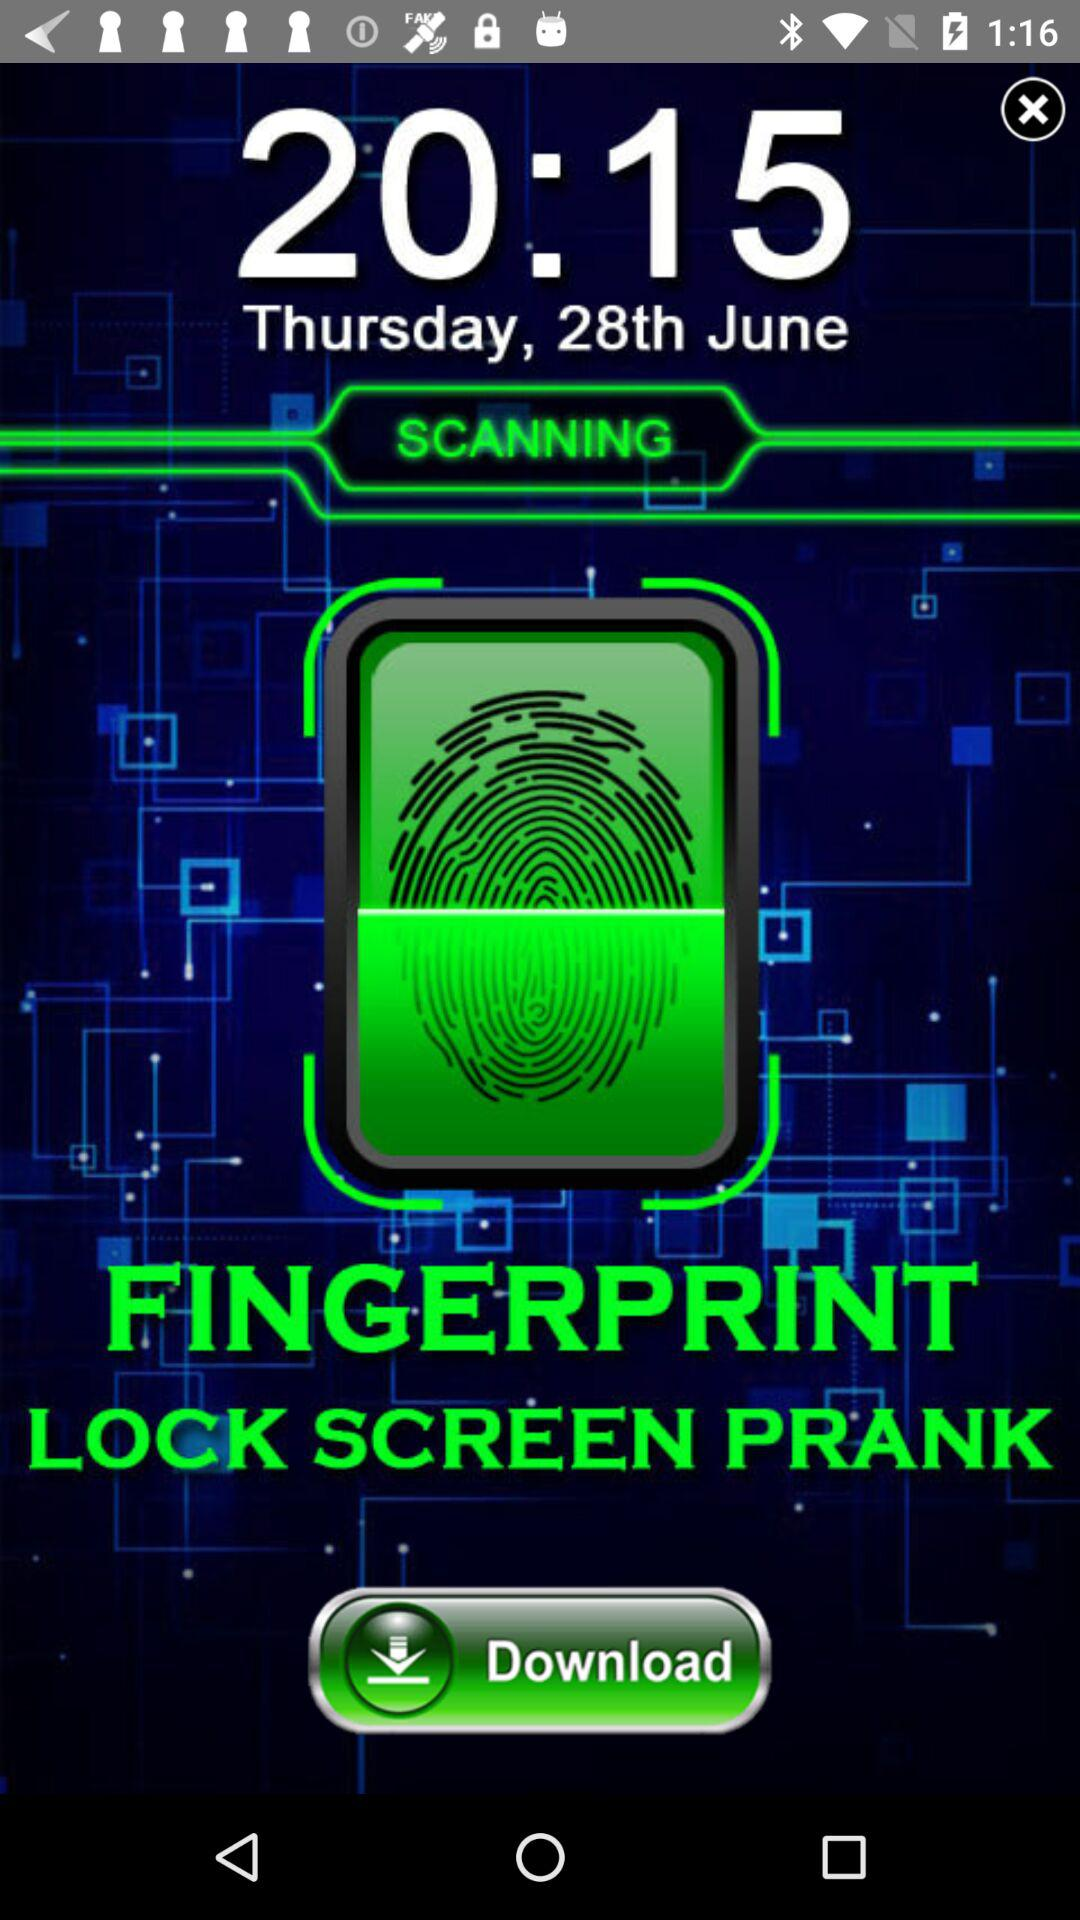What is the time? The time is 20:15. 